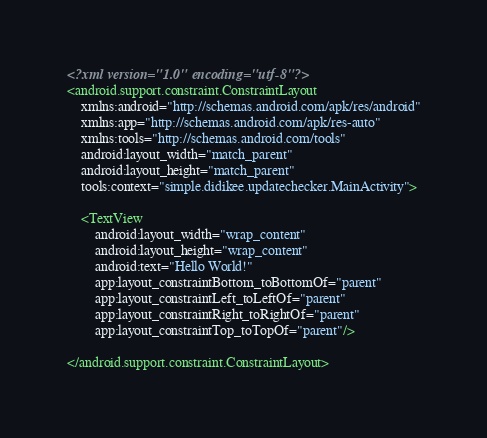Convert code to text. <code><loc_0><loc_0><loc_500><loc_500><_XML_><?xml version="1.0" encoding="utf-8"?>
<android.support.constraint.ConstraintLayout
    xmlns:android="http://schemas.android.com/apk/res/android"
    xmlns:app="http://schemas.android.com/apk/res-auto"
    xmlns:tools="http://schemas.android.com/tools"
    android:layout_width="match_parent"
    android:layout_height="match_parent"
    tools:context="simple.didikee.updatechecker.MainActivity">

    <TextView
        android:layout_width="wrap_content"
        android:layout_height="wrap_content"
        android:text="Hello World!"
        app:layout_constraintBottom_toBottomOf="parent"
        app:layout_constraintLeft_toLeftOf="parent"
        app:layout_constraintRight_toRightOf="parent"
        app:layout_constraintTop_toTopOf="parent"/>

</android.support.constraint.ConstraintLayout>
</code> 